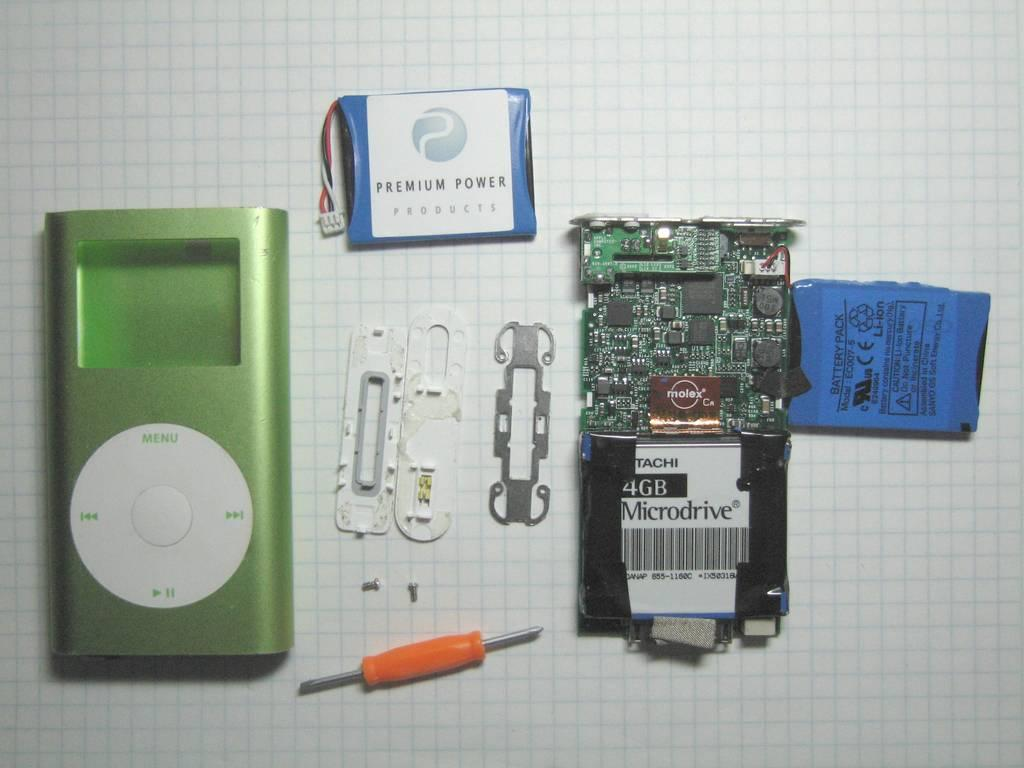What is present on the wall in the image? There is a screwdriver, a chipboard, and a remote attached to the wall in the image. Are there any other objects attached to the wall? Yes, there are other objects attached to the wall. What is the purpose of the screwdriver on the wall? The purpose of the screwdriver on the wall is not clear from the image, but it may be used for fixing or assembling items. What type of food is being prepared on the wall in the image? There is no food or preparation of food visible in the image. How many stars can be seen on the wall in the image? There are no stars present on the wall in the image. 